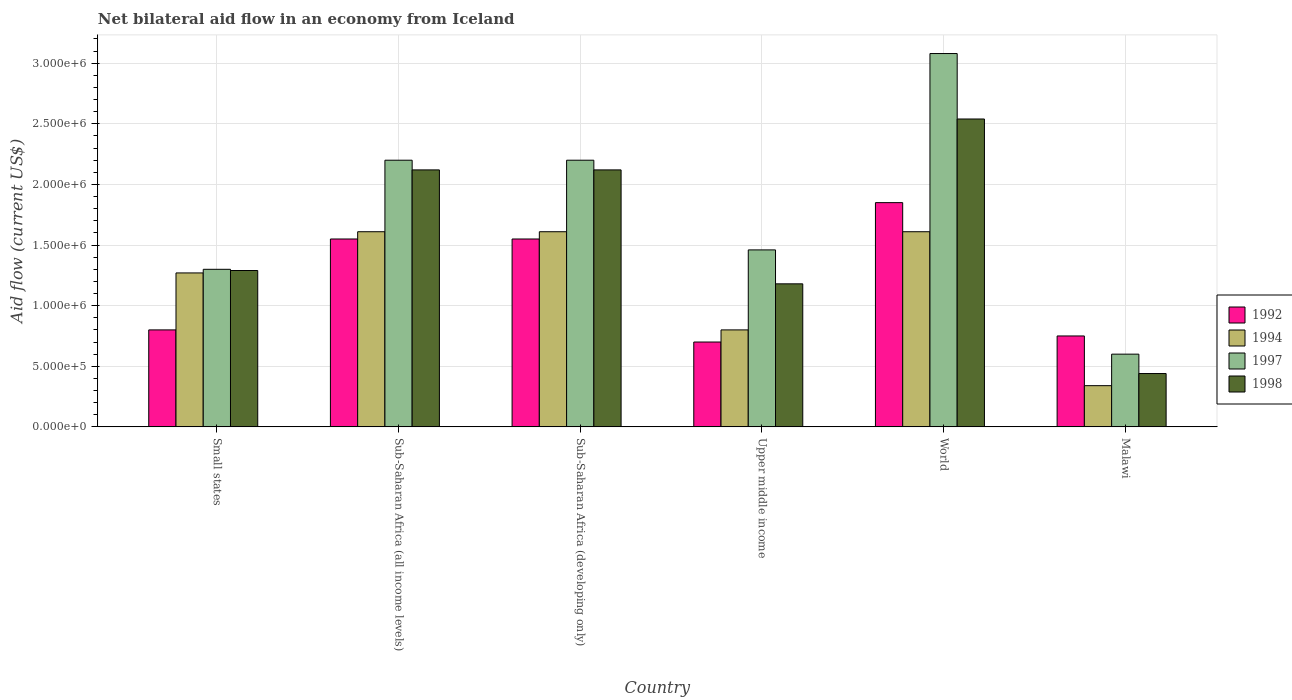How many different coloured bars are there?
Offer a very short reply. 4. How many groups of bars are there?
Your response must be concise. 6. How many bars are there on the 5th tick from the right?
Keep it short and to the point. 4. What is the label of the 6th group of bars from the left?
Ensure brevity in your answer.  Malawi. In how many cases, is the number of bars for a given country not equal to the number of legend labels?
Provide a short and direct response. 0. What is the net bilateral aid flow in 1994 in Upper middle income?
Provide a succinct answer. 8.00e+05. Across all countries, what is the maximum net bilateral aid flow in 1997?
Provide a succinct answer. 3.08e+06. Across all countries, what is the minimum net bilateral aid flow in 1992?
Make the answer very short. 7.00e+05. In which country was the net bilateral aid flow in 1994 maximum?
Your response must be concise. Sub-Saharan Africa (all income levels). In which country was the net bilateral aid flow in 1994 minimum?
Offer a very short reply. Malawi. What is the total net bilateral aid flow in 1992 in the graph?
Provide a short and direct response. 7.20e+06. What is the difference between the net bilateral aid flow in 1998 in Malawi and that in Sub-Saharan Africa (developing only)?
Your response must be concise. -1.68e+06. What is the difference between the net bilateral aid flow in 1992 in Malawi and the net bilateral aid flow in 1998 in Upper middle income?
Your answer should be very brief. -4.30e+05. What is the average net bilateral aid flow in 1997 per country?
Give a very brief answer. 1.81e+06. What is the difference between the net bilateral aid flow of/in 1994 and net bilateral aid flow of/in 1992 in Malawi?
Ensure brevity in your answer.  -4.10e+05. What is the ratio of the net bilateral aid flow in 1994 in Sub-Saharan Africa (developing only) to that in Upper middle income?
Make the answer very short. 2.01. What is the difference between the highest and the lowest net bilateral aid flow in 1992?
Your response must be concise. 1.15e+06. Is the sum of the net bilateral aid flow in 1992 in Sub-Saharan Africa (developing only) and Upper middle income greater than the maximum net bilateral aid flow in 1998 across all countries?
Ensure brevity in your answer.  No. How many bars are there?
Your answer should be very brief. 24. What is the title of the graph?
Make the answer very short. Net bilateral aid flow in an economy from Iceland. What is the label or title of the X-axis?
Make the answer very short. Country. What is the label or title of the Y-axis?
Your answer should be compact. Aid flow (current US$). What is the Aid flow (current US$) of 1992 in Small states?
Provide a succinct answer. 8.00e+05. What is the Aid flow (current US$) of 1994 in Small states?
Offer a very short reply. 1.27e+06. What is the Aid flow (current US$) of 1997 in Small states?
Provide a succinct answer. 1.30e+06. What is the Aid flow (current US$) of 1998 in Small states?
Offer a terse response. 1.29e+06. What is the Aid flow (current US$) of 1992 in Sub-Saharan Africa (all income levels)?
Offer a very short reply. 1.55e+06. What is the Aid flow (current US$) of 1994 in Sub-Saharan Africa (all income levels)?
Your response must be concise. 1.61e+06. What is the Aid flow (current US$) of 1997 in Sub-Saharan Africa (all income levels)?
Your answer should be compact. 2.20e+06. What is the Aid flow (current US$) of 1998 in Sub-Saharan Africa (all income levels)?
Make the answer very short. 2.12e+06. What is the Aid flow (current US$) of 1992 in Sub-Saharan Africa (developing only)?
Offer a terse response. 1.55e+06. What is the Aid flow (current US$) in 1994 in Sub-Saharan Africa (developing only)?
Your answer should be compact. 1.61e+06. What is the Aid flow (current US$) in 1997 in Sub-Saharan Africa (developing only)?
Your answer should be very brief. 2.20e+06. What is the Aid flow (current US$) of 1998 in Sub-Saharan Africa (developing only)?
Provide a succinct answer. 2.12e+06. What is the Aid flow (current US$) in 1992 in Upper middle income?
Provide a short and direct response. 7.00e+05. What is the Aid flow (current US$) of 1994 in Upper middle income?
Keep it short and to the point. 8.00e+05. What is the Aid flow (current US$) in 1997 in Upper middle income?
Offer a terse response. 1.46e+06. What is the Aid flow (current US$) of 1998 in Upper middle income?
Keep it short and to the point. 1.18e+06. What is the Aid flow (current US$) in 1992 in World?
Your response must be concise. 1.85e+06. What is the Aid flow (current US$) of 1994 in World?
Your answer should be compact. 1.61e+06. What is the Aid flow (current US$) of 1997 in World?
Provide a succinct answer. 3.08e+06. What is the Aid flow (current US$) in 1998 in World?
Provide a succinct answer. 2.54e+06. What is the Aid flow (current US$) in 1992 in Malawi?
Keep it short and to the point. 7.50e+05. What is the Aid flow (current US$) of 1994 in Malawi?
Ensure brevity in your answer.  3.40e+05. What is the Aid flow (current US$) in 1997 in Malawi?
Make the answer very short. 6.00e+05. Across all countries, what is the maximum Aid flow (current US$) of 1992?
Provide a succinct answer. 1.85e+06. Across all countries, what is the maximum Aid flow (current US$) of 1994?
Keep it short and to the point. 1.61e+06. Across all countries, what is the maximum Aid flow (current US$) of 1997?
Your answer should be compact. 3.08e+06. Across all countries, what is the maximum Aid flow (current US$) in 1998?
Keep it short and to the point. 2.54e+06. Across all countries, what is the minimum Aid flow (current US$) of 1997?
Provide a succinct answer. 6.00e+05. Across all countries, what is the minimum Aid flow (current US$) in 1998?
Provide a succinct answer. 4.40e+05. What is the total Aid flow (current US$) in 1992 in the graph?
Offer a very short reply. 7.20e+06. What is the total Aid flow (current US$) in 1994 in the graph?
Your answer should be very brief. 7.24e+06. What is the total Aid flow (current US$) in 1997 in the graph?
Ensure brevity in your answer.  1.08e+07. What is the total Aid flow (current US$) of 1998 in the graph?
Make the answer very short. 9.69e+06. What is the difference between the Aid flow (current US$) in 1992 in Small states and that in Sub-Saharan Africa (all income levels)?
Provide a succinct answer. -7.50e+05. What is the difference between the Aid flow (current US$) in 1994 in Small states and that in Sub-Saharan Africa (all income levels)?
Keep it short and to the point. -3.40e+05. What is the difference between the Aid flow (current US$) in 1997 in Small states and that in Sub-Saharan Africa (all income levels)?
Ensure brevity in your answer.  -9.00e+05. What is the difference between the Aid flow (current US$) in 1998 in Small states and that in Sub-Saharan Africa (all income levels)?
Keep it short and to the point. -8.30e+05. What is the difference between the Aid flow (current US$) of 1992 in Small states and that in Sub-Saharan Africa (developing only)?
Keep it short and to the point. -7.50e+05. What is the difference between the Aid flow (current US$) in 1994 in Small states and that in Sub-Saharan Africa (developing only)?
Keep it short and to the point. -3.40e+05. What is the difference between the Aid flow (current US$) in 1997 in Small states and that in Sub-Saharan Africa (developing only)?
Give a very brief answer. -9.00e+05. What is the difference between the Aid flow (current US$) of 1998 in Small states and that in Sub-Saharan Africa (developing only)?
Provide a short and direct response. -8.30e+05. What is the difference between the Aid flow (current US$) in 1992 in Small states and that in Upper middle income?
Make the answer very short. 1.00e+05. What is the difference between the Aid flow (current US$) of 1994 in Small states and that in Upper middle income?
Keep it short and to the point. 4.70e+05. What is the difference between the Aid flow (current US$) of 1992 in Small states and that in World?
Provide a short and direct response. -1.05e+06. What is the difference between the Aid flow (current US$) of 1994 in Small states and that in World?
Offer a terse response. -3.40e+05. What is the difference between the Aid flow (current US$) of 1997 in Small states and that in World?
Your response must be concise. -1.78e+06. What is the difference between the Aid flow (current US$) in 1998 in Small states and that in World?
Keep it short and to the point. -1.25e+06. What is the difference between the Aid flow (current US$) in 1994 in Small states and that in Malawi?
Give a very brief answer. 9.30e+05. What is the difference between the Aid flow (current US$) of 1997 in Small states and that in Malawi?
Keep it short and to the point. 7.00e+05. What is the difference between the Aid flow (current US$) in 1998 in Small states and that in Malawi?
Your answer should be very brief. 8.50e+05. What is the difference between the Aid flow (current US$) of 1992 in Sub-Saharan Africa (all income levels) and that in Sub-Saharan Africa (developing only)?
Your response must be concise. 0. What is the difference between the Aid flow (current US$) of 1997 in Sub-Saharan Africa (all income levels) and that in Sub-Saharan Africa (developing only)?
Provide a succinct answer. 0. What is the difference between the Aid flow (current US$) of 1992 in Sub-Saharan Africa (all income levels) and that in Upper middle income?
Ensure brevity in your answer.  8.50e+05. What is the difference between the Aid flow (current US$) in 1994 in Sub-Saharan Africa (all income levels) and that in Upper middle income?
Make the answer very short. 8.10e+05. What is the difference between the Aid flow (current US$) in 1997 in Sub-Saharan Africa (all income levels) and that in Upper middle income?
Your answer should be very brief. 7.40e+05. What is the difference between the Aid flow (current US$) of 1998 in Sub-Saharan Africa (all income levels) and that in Upper middle income?
Make the answer very short. 9.40e+05. What is the difference between the Aid flow (current US$) in 1994 in Sub-Saharan Africa (all income levels) and that in World?
Your response must be concise. 0. What is the difference between the Aid flow (current US$) in 1997 in Sub-Saharan Africa (all income levels) and that in World?
Provide a succinct answer. -8.80e+05. What is the difference between the Aid flow (current US$) of 1998 in Sub-Saharan Africa (all income levels) and that in World?
Your answer should be very brief. -4.20e+05. What is the difference between the Aid flow (current US$) of 1992 in Sub-Saharan Africa (all income levels) and that in Malawi?
Your answer should be compact. 8.00e+05. What is the difference between the Aid flow (current US$) of 1994 in Sub-Saharan Africa (all income levels) and that in Malawi?
Keep it short and to the point. 1.27e+06. What is the difference between the Aid flow (current US$) of 1997 in Sub-Saharan Africa (all income levels) and that in Malawi?
Make the answer very short. 1.60e+06. What is the difference between the Aid flow (current US$) of 1998 in Sub-Saharan Africa (all income levels) and that in Malawi?
Offer a very short reply. 1.68e+06. What is the difference between the Aid flow (current US$) in 1992 in Sub-Saharan Africa (developing only) and that in Upper middle income?
Provide a short and direct response. 8.50e+05. What is the difference between the Aid flow (current US$) of 1994 in Sub-Saharan Africa (developing only) and that in Upper middle income?
Make the answer very short. 8.10e+05. What is the difference between the Aid flow (current US$) of 1997 in Sub-Saharan Africa (developing only) and that in Upper middle income?
Your answer should be very brief. 7.40e+05. What is the difference between the Aid flow (current US$) of 1998 in Sub-Saharan Africa (developing only) and that in Upper middle income?
Your response must be concise. 9.40e+05. What is the difference between the Aid flow (current US$) of 1994 in Sub-Saharan Africa (developing only) and that in World?
Make the answer very short. 0. What is the difference between the Aid flow (current US$) of 1997 in Sub-Saharan Africa (developing only) and that in World?
Provide a succinct answer. -8.80e+05. What is the difference between the Aid flow (current US$) in 1998 in Sub-Saharan Africa (developing only) and that in World?
Your response must be concise. -4.20e+05. What is the difference between the Aid flow (current US$) of 1994 in Sub-Saharan Africa (developing only) and that in Malawi?
Make the answer very short. 1.27e+06. What is the difference between the Aid flow (current US$) in 1997 in Sub-Saharan Africa (developing only) and that in Malawi?
Ensure brevity in your answer.  1.60e+06. What is the difference between the Aid flow (current US$) of 1998 in Sub-Saharan Africa (developing only) and that in Malawi?
Give a very brief answer. 1.68e+06. What is the difference between the Aid flow (current US$) of 1992 in Upper middle income and that in World?
Provide a succinct answer. -1.15e+06. What is the difference between the Aid flow (current US$) of 1994 in Upper middle income and that in World?
Offer a very short reply. -8.10e+05. What is the difference between the Aid flow (current US$) in 1997 in Upper middle income and that in World?
Your response must be concise. -1.62e+06. What is the difference between the Aid flow (current US$) of 1998 in Upper middle income and that in World?
Your answer should be very brief. -1.36e+06. What is the difference between the Aid flow (current US$) in 1997 in Upper middle income and that in Malawi?
Keep it short and to the point. 8.60e+05. What is the difference between the Aid flow (current US$) of 1998 in Upper middle income and that in Malawi?
Give a very brief answer. 7.40e+05. What is the difference between the Aid flow (current US$) of 1992 in World and that in Malawi?
Keep it short and to the point. 1.10e+06. What is the difference between the Aid flow (current US$) in 1994 in World and that in Malawi?
Your response must be concise. 1.27e+06. What is the difference between the Aid flow (current US$) in 1997 in World and that in Malawi?
Your answer should be compact. 2.48e+06. What is the difference between the Aid flow (current US$) of 1998 in World and that in Malawi?
Provide a short and direct response. 2.10e+06. What is the difference between the Aid flow (current US$) of 1992 in Small states and the Aid flow (current US$) of 1994 in Sub-Saharan Africa (all income levels)?
Provide a short and direct response. -8.10e+05. What is the difference between the Aid flow (current US$) of 1992 in Small states and the Aid flow (current US$) of 1997 in Sub-Saharan Africa (all income levels)?
Make the answer very short. -1.40e+06. What is the difference between the Aid flow (current US$) in 1992 in Small states and the Aid flow (current US$) in 1998 in Sub-Saharan Africa (all income levels)?
Give a very brief answer. -1.32e+06. What is the difference between the Aid flow (current US$) in 1994 in Small states and the Aid flow (current US$) in 1997 in Sub-Saharan Africa (all income levels)?
Your response must be concise. -9.30e+05. What is the difference between the Aid flow (current US$) of 1994 in Small states and the Aid flow (current US$) of 1998 in Sub-Saharan Africa (all income levels)?
Keep it short and to the point. -8.50e+05. What is the difference between the Aid flow (current US$) of 1997 in Small states and the Aid flow (current US$) of 1998 in Sub-Saharan Africa (all income levels)?
Offer a very short reply. -8.20e+05. What is the difference between the Aid flow (current US$) in 1992 in Small states and the Aid flow (current US$) in 1994 in Sub-Saharan Africa (developing only)?
Your response must be concise. -8.10e+05. What is the difference between the Aid flow (current US$) of 1992 in Small states and the Aid flow (current US$) of 1997 in Sub-Saharan Africa (developing only)?
Your answer should be compact. -1.40e+06. What is the difference between the Aid flow (current US$) of 1992 in Small states and the Aid flow (current US$) of 1998 in Sub-Saharan Africa (developing only)?
Offer a terse response. -1.32e+06. What is the difference between the Aid flow (current US$) in 1994 in Small states and the Aid flow (current US$) in 1997 in Sub-Saharan Africa (developing only)?
Ensure brevity in your answer.  -9.30e+05. What is the difference between the Aid flow (current US$) of 1994 in Small states and the Aid flow (current US$) of 1998 in Sub-Saharan Africa (developing only)?
Keep it short and to the point. -8.50e+05. What is the difference between the Aid flow (current US$) in 1997 in Small states and the Aid flow (current US$) in 1998 in Sub-Saharan Africa (developing only)?
Offer a very short reply. -8.20e+05. What is the difference between the Aid flow (current US$) in 1992 in Small states and the Aid flow (current US$) in 1997 in Upper middle income?
Provide a succinct answer. -6.60e+05. What is the difference between the Aid flow (current US$) in 1992 in Small states and the Aid flow (current US$) in 1998 in Upper middle income?
Your response must be concise. -3.80e+05. What is the difference between the Aid flow (current US$) in 1994 in Small states and the Aid flow (current US$) in 1997 in Upper middle income?
Offer a very short reply. -1.90e+05. What is the difference between the Aid flow (current US$) in 1994 in Small states and the Aid flow (current US$) in 1998 in Upper middle income?
Keep it short and to the point. 9.00e+04. What is the difference between the Aid flow (current US$) in 1997 in Small states and the Aid flow (current US$) in 1998 in Upper middle income?
Keep it short and to the point. 1.20e+05. What is the difference between the Aid flow (current US$) of 1992 in Small states and the Aid flow (current US$) of 1994 in World?
Your answer should be very brief. -8.10e+05. What is the difference between the Aid flow (current US$) in 1992 in Small states and the Aid flow (current US$) in 1997 in World?
Your answer should be very brief. -2.28e+06. What is the difference between the Aid flow (current US$) of 1992 in Small states and the Aid flow (current US$) of 1998 in World?
Offer a terse response. -1.74e+06. What is the difference between the Aid flow (current US$) in 1994 in Small states and the Aid flow (current US$) in 1997 in World?
Ensure brevity in your answer.  -1.81e+06. What is the difference between the Aid flow (current US$) of 1994 in Small states and the Aid flow (current US$) of 1998 in World?
Your response must be concise. -1.27e+06. What is the difference between the Aid flow (current US$) of 1997 in Small states and the Aid flow (current US$) of 1998 in World?
Offer a very short reply. -1.24e+06. What is the difference between the Aid flow (current US$) in 1992 in Small states and the Aid flow (current US$) in 1997 in Malawi?
Your answer should be compact. 2.00e+05. What is the difference between the Aid flow (current US$) of 1994 in Small states and the Aid flow (current US$) of 1997 in Malawi?
Give a very brief answer. 6.70e+05. What is the difference between the Aid flow (current US$) of 1994 in Small states and the Aid flow (current US$) of 1998 in Malawi?
Your answer should be compact. 8.30e+05. What is the difference between the Aid flow (current US$) of 1997 in Small states and the Aid flow (current US$) of 1998 in Malawi?
Offer a very short reply. 8.60e+05. What is the difference between the Aid flow (current US$) in 1992 in Sub-Saharan Africa (all income levels) and the Aid flow (current US$) in 1994 in Sub-Saharan Africa (developing only)?
Your answer should be compact. -6.00e+04. What is the difference between the Aid flow (current US$) of 1992 in Sub-Saharan Africa (all income levels) and the Aid flow (current US$) of 1997 in Sub-Saharan Africa (developing only)?
Your response must be concise. -6.50e+05. What is the difference between the Aid flow (current US$) of 1992 in Sub-Saharan Africa (all income levels) and the Aid flow (current US$) of 1998 in Sub-Saharan Africa (developing only)?
Ensure brevity in your answer.  -5.70e+05. What is the difference between the Aid flow (current US$) in 1994 in Sub-Saharan Africa (all income levels) and the Aid flow (current US$) in 1997 in Sub-Saharan Africa (developing only)?
Offer a very short reply. -5.90e+05. What is the difference between the Aid flow (current US$) of 1994 in Sub-Saharan Africa (all income levels) and the Aid flow (current US$) of 1998 in Sub-Saharan Africa (developing only)?
Provide a succinct answer. -5.10e+05. What is the difference between the Aid flow (current US$) of 1992 in Sub-Saharan Africa (all income levels) and the Aid flow (current US$) of 1994 in Upper middle income?
Offer a very short reply. 7.50e+05. What is the difference between the Aid flow (current US$) of 1992 in Sub-Saharan Africa (all income levels) and the Aid flow (current US$) of 1997 in Upper middle income?
Give a very brief answer. 9.00e+04. What is the difference between the Aid flow (current US$) in 1994 in Sub-Saharan Africa (all income levels) and the Aid flow (current US$) in 1998 in Upper middle income?
Your response must be concise. 4.30e+05. What is the difference between the Aid flow (current US$) of 1997 in Sub-Saharan Africa (all income levels) and the Aid flow (current US$) of 1998 in Upper middle income?
Ensure brevity in your answer.  1.02e+06. What is the difference between the Aid flow (current US$) of 1992 in Sub-Saharan Africa (all income levels) and the Aid flow (current US$) of 1994 in World?
Ensure brevity in your answer.  -6.00e+04. What is the difference between the Aid flow (current US$) in 1992 in Sub-Saharan Africa (all income levels) and the Aid flow (current US$) in 1997 in World?
Provide a short and direct response. -1.53e+06. What is the difference between the Aid flow (current US$) of 1992 in Sub-Saharan Africa (all income levels) and the Aid flow (current US$) of 1998 in World?
Your answer should be very brief. -9.90e+05. What is the difference between the Aid flow (current US$) in 1994 in Sub-Saharan Africa (all income levels) and the Aid flow (current US$) in 1997 in World?
Keep it short and to the point. -1.47e+06. What is the difference between the Aid flow (current US$) of 1994 in Sub-Saharan Africa (all income levels) and the Aid flow (current US$) of 1998 in World?
Your response must be concise. -9.30e+05. What is the difference between the Aid flow (current US$) of 1992 in Sub-Saharan Africa (all income levels) and the Aid flow (current US$) of 1994 in Malawi?
Make the answer very short. 1.21e+06. What is the difference between the Aid flow (current US$) in 1992 in Sub-Saharan Africa (all income levels) and the Aid flow (current US$) in 1997 in Malawi?
Provide a succinct answer. 9.50e+05. What is the difference between the Aid flow (current US$) in 1992 in Sub-Saharan Africa (all income levels) and the Aid flow (current US$) in 1998 in Malawi?
Offer a very short reply. 1.11e+06. What is the difference between the Aid flow (current US$) of 1994 in Sub-Saharan Africa (all income levels) and the Aid flow (current US$) of 1997 in Malawi?
Keep it short and to the point. 1.01e+06. What is the difference between the Aid flow (current US$) of 1994 in Sub-Saharan Africa (all income levels) and the Aid flow (current US$) of 1998 in Malawi?
Your response must be concise. 1.17e+06. What is the difference between the Aid flow (current US$) of 1997 in Sub-Saharan Africa (all income levels) and the Aid flow (current US$) of 1998 in Malawi?
Your answer should be compact. 1.76e+06. What is the difference between the Aid flow (current US$) of 1992 in Sub-Saharan Africa (developing only) and the Aid flow (current US$) of 1994 in Upper middle income?
Make the answer very short. 7.50e+05. What is the difference between the Aid flow (current US$) in 1997 in Sub-Saharan Africa (developing only) and the Aid flow (current US$) in 1998 in Upper middle income?
Your answer should be very brief. 1.02e+06. What is the difference between the Aid flow (current US$) of 1992 in Sub-Saharan Africa (developing only) and the Aid flow (current US$) of 1994 in World?
Make the answer very short. -6.00e+04. What is the difference between the Aid flow (current US$) in 1992 in Sub-Saharan Africa (developing only) and the Aid flow (current US$) in 1997 in World?
Your answer should be very brief. -1.53e+06. What is the difference between the Aid flow (current US$) of 1992 in Sub-Saharan Africa (developing only) and the Aid flow (current US$) of 1998 in World?
Keep it short and to the point. -9.90e+05. What is the difference between the Aid flow (current US$) of 1994 in Sub-Saharan Africa (developing only) and the Aid flow (current US$) of 1997 in World?
Keep it short and to the point. -1.47e+06. What is the difference between the Aid flow (current US$) of 1994 in Sub-Saharan Africa (developing only) and the Aid flow (current US$) of 1998 in World?
Make the answer very short. -9.30e+05. What is the difference between the Aid flow (current US$) in 1997 in Sub-Saharan Africa (developing only) and the Aid flow (current US$) in 1998 in World?
Offer a very short reply. -3.40e+05. What is the difference between the Aid flow (current US$) of 1992 in Sub-Saharan Africa (developing only) and the Aid flow (current US$) of 1994 in Malawi?
Ensure brevity in your answer.  1.21e+06. What is the difference between the Aid flow (current US$) in 1992 in Sub-Saharan Africa (developing only) and the Aid flow (current US$) in 1997 in Malawi?
Offer a very short reply. 9.50e+05. What is the difference between the Aid flow (current US$) in 1992 in Sub-Saharan Africa (developing only) and the Aid flow (current US$) in 1998 in Malawi?
Your answer should be compact. 1.11e+06. What is the difference between the Aid flow (current US$) in 1994 in Sub-Saharan Africa (developing only) and the Aid flow (current US$) in 1997 in Malawi?
Keep it short and to the point. 1.01e+06. What is the difference between the Aid flow (current US$) in 1994 in Sub-Saharan Africa (developing only) and the Aid flow (current US$) in 1998 in Malawi?
Offer a terse response. 1.17e+06. What is the difference between the Aid flow (current US$) in 1997 in Sub-Saharan Africa (developing only) and the Aid flow (current US$) in 1998 in Malawi?
Your response must be concise. 1.76e+06. What is the difference between the Aid flow (current US$) of 1992 in Upper middle income and the Aid flow (current US$) of 1994 in World?
Ensure brevity in your answer.  -9.10e+05. What is the difference between the Aid flow (current US$) of 1992 in Upper middle income and the Aid flow (current US$) of 1997 in World?
Your answer should be very brief. -2.38e+06. What is the difference between the Aid flow (current US$) of 1992 in Upper middle income and the Aid flow (current US$) of 1998 in World?
Make the answer very short. -1.84e+06. What is the difference between the Aid flow (current US$) of 1994 in Upper middle income and the Aid flow (current US$) of 1997 in World?
Provide a succinct answer. -2.28e+06. What is the difference between the Aid flow (current US$) in 1994 in Upper middle income and the Aid flow (current US$) in 1998 in World?
Make the answer very short. -1.74e+06. What is the difference between the Aid flow (current US$) of 1997 in Upper middle income and the Aid flow (current US$) of 1998 in World?
Offer a terse response. -1.08e+06. What is the difference between the Aid flow (current US$) of 1994 in Upper middle income and the Aid flow (current US$) of 1998 in Malawi?
Provide a succinct answer. 3.60e+05. What is the difference between the Aid flow (current US$) of 1997 in Upper middle income and the Aid flow (current US$) of 1998 in Malawi?
Offer a terse response. 1.02e+06. What is the difference between the Aid flow (current US$) of 1992 in World and the Aid flow (current US$) of 1994 in Malawi?
Offer a terse response. 1.51e+06. What is the difference between the Aid flow (current US$) of 1992 in World and the Aid flow (current US$) of 1997 in Malawi?
Offer a terse response. 1.25e+06. What is the difference between the Aid flow (current US$) of 1992 in World and the Aid flow (current US$) of 1998 in Malawi?
Provide a short and direct response. 1.41e+06. What is the difference between the Aid flow (current US$) of 1994 in World and the Aid flow (current US$) of 1997 in Malawi?
Keep it short and to the point. 1.01e+06. What is the difference between the Aid flow (current US$) in 1994 in World and the Aid flow (current US$) in 1998 in Malawi?
Provide a succinct answer. 1.17e+06. What is the difference between the Aid flow (current US$) of 1997 in World and the Aid flow (current US$) of 1998 in Malawi?
Make the answer very short. 2.64e+06. What is the average Aid flow (current US$) of 1992 per country?
Give a very brief answer. 1.20e+06. What is the average Aid flow (current US$) of 1994 per country?
Provide a short and direct response. 1.21e+06. What is the average Aid flow (current US$) in 1997 per country?
Provide a short and direct response. 1.81e+06. What is the average Aid flow (current US$) of 1998 per country?
Your answer should be compact. 1.62e+06. What is the difference between the Aid flow (current US$) in 1992 and Aid flow (current US$) in 1994 in Small states?
Ensure brevity in your answer.  -4.70e+05. What is the difference between the Aid flow (current US$) of 1992 and Aid flow (current US$) of 1997 in Small states?
Offer a very short reply. -5.00e+05. What is the difference between the Aid flow (current US$) of 1992 and Aid flow (current US$) of 1998 in Small states?
Provide a short and direct response. -4.90e+05. What is the difference between the Aid flow (current US$) in 1994 and Aid flow (current US$) in 1998 in Small states?
Ensure brevity in your answer.  -2.00e+04. What is the difference between the Aid flow (current US$) in 1992 and Aid flow (current US$) in 1994 in Sub-Saharan Africa (all income levels)?
Offer a very short reply. -6.00e+04. What is the difference between the Aid flow (current US$) of 1992 and Aid flow (current US$) of 1997 in Sub-Saharan Africa (all income levels)?
Offer a very short reply. -6.50e+05. What is the difference between the Aid flow (current US$) in 1992 and Aid flow (current US$) in 1998 in Sub-Saharan Africa (all income levels)?
Provide a succinct answer. -5.70e+05. What is the difference between the Aid flow (current US$) of 1994 and Aid flow (current US$) of 1997 in Sub-Saharan Africa (all income levels)?
Keep it short and to the point. -5.90e+05. What is the difference between the Aid flow (current US$) in 1994 and Aid flow (current US$) in 1998 in Sub-Saharan Africa (all income levels)?
Give a very brief answer. -5.10e+05. What is the difference between the Aid flow (current US$) of 1997 and Aid flow (current US$) of 1998 in Sub-Saharan Africa (all income levels)?
Give a very brief answer. 8.00e+04. What is the difference between the Aid flow (current US$) in 1992 and Aid flow (current US$) in 1997 in Sub-Saharan Africa (developing only)?
Give a very brief answer. -6.50e+05. What is the difference between the Aid flow (current US$) of 1992 and Aid flow (current US$) of 1998 in Sub-Saharan Africa (developing only)?
Offer a terse response. -5.70e+05. What is the difference between the Aid flow (current US$) of 1994 and Aid flow (current US$) of 1997 in Sub-Saharan Africa (developing only)?
Your answer should be very brief. -5.90e+05. What is the difference between the Aid flow (current US$) of 1994 and Aid flow (current US$) of 1998 in Sub-Saharan Africa (developing only)?
Ensure brevity in your answer.  -5.10e+05. What is the difference between the Aid flow (current US$) of 1997 and Aid flow (current US$) of 1998 in Sub-Saharan Africa (developing only)?
Provide a succinct answer. 8.00e+04. What is the difference between the Aid flow (current US$) of 1992 and Aid flow (current US$) of 1997 in Upper middle income?
Give a very brief answer. -7.60e+05. What is the difference between the Aid flow (current US$) of 1992 and Aid flow (current US$) of 1998 in Upper middle income?
Ensure brevity in your answer.  -4.80e+05. What is the difference between the Aid flow (current US$) in 1994 and Aid flow (current US$) in 1997 in Upper middle income?
Give a very brief answer. -6.60e+05. What is the difference between the Aid flow (current US$) in 1994 and Aid flow (current US$) in 1998 in Upper middle income?
Make the answer very short. -3.80e+05. What is the difference between the Aid flow (current US$) in 1992 and Aid flow (current US$) in 1994 in World?
Offer a terse response. 2.40e+05. What is the difference between the Aid flow (current US$) of 1992 and Aid flow (current US$) of 1997 in World?
Offer a very short reply. -1.23e+06. What is the difference between the Aid flow (current US$) in 1992 and Aid flow (current US$) in 1998 in World?
Offer a terse response. -6.90e+05. What is the difference between the Aid flow (current US$) in 1994 and Aid flow (current US$) in 1997 in World?
Ensure brevity in your answer.  -1.47e+06. What is the difference between the Aid flow (current US$) of 1994 and Aid flow (current US$) of 1998 in World?
Provide a short and direct response. -9.30e+05. What is the difference between the Aid flow (current US$) in 1997 and Aid flow (current US$) in 1998 in World?
Your answer should be very brief. 5.40e+05. What is the difference between the Aid flow (current US$) of 1992 and Aid flow (current US$) of 1994 in Malawi?
Your answer should be compact. 4.10e+05. What is the difference between the Aid flow (current US$) in 1992 and Aid flow (current US$) in 1997 in Malawi?
Your answer should be very brief. 1.50e+05. What is the difference between the Aid flow (current US$) in 1994 and Aid flow (current US$) in 1998 in Malawi?
Give a very brief answer. -1.00e+05. What is the ratio of the Aid flow (current US$) of 1992 in Small states to that in Sub-Saharan Africa (all income levels)?
Provide a succinct answer. 0.52. What is the ratio of the Aid flow (current US$) in 1994 in Small states to that in Sub-Saharan Africa (all income levels)?
Ensure brevity in your answer.  0.79. What is the ratio of the Aid flow (current US$) of 1997 in Small states to that in Sub-Saharan Africa (all income levels)?
Ensure brevity in your answer.  0.59. What is the ratio of the Aid flow (current US$) in 1998 in Small states to that in Sub-Saharan Africa (all income levels)?
Make the answer very short. 0.61. What is the ratio of the Aid flow (current US$) in 1992 in Small states to that in Sub-Saharan Africa (developing only)?
Offer a very short reply. 0.52. What is the ratio of the Aid flow (current US$) in 1994 in Small states to that in Sub-Saharan Africa (developing only)?
Keep it short and to the point. 0.79. What is the ratio of the Aid flow (current US$) of 1997 in Small states to that in Sub-Saharan Africa (developing only)?
Provide a short and direct response. 0.59. What is the ratio of the Aid flow (current US$) in 1998 in Small states to that in Sub-Saharan Africa (developing only)?
Provide a succinct answer. 0.61. What is the ratio of the Aid flow (current US$) in 1994 in Small states to that in Upper middle income?
Your response must be concise. 1.59. What is the ratio of the Aid flow (current US$) of 1997 in Small states to that in Upper middle income?
Your answer should be very brief. 0.89. What is the ratio of the Aid flow (current US$) in 1998 in Small states to that in Upper middle income?
Offer a terse response. 1.09. What is the ratio of the Aid flow (current US$) of 1992 in Small states to that in World?
Provide a short and direct response. 0.43. What is the ratio of the Aid flow (current US$) in 1994 in Small states to that in World?
Offer a terse response. 0.79. What is the ratio of the Aid flow (current US$) in 1997 in Small states to that in World?
Make the answer very short. 0.42. What is the ratio of the Aid flow (current US$) of 1998 in Small states to that in World?
Your answer should be very brief. 0.51. What is the ratio of the Aid flow (current US$) in 1992 in Small states to that in Malawi?
Offer a very short reply. 1.07. What is the ratio of the Aid flow (current US$) of 1994 in Small states to that in Malawi?
Make the answer very short. 3.74. What is the ratio of the Aid flow (current US$) of 1997 in Small states to that in Malawi?
Your answer should be compact. 2.17. What is the ratio of the Aid flow (current US$) in 1998 in Small states to that in Malawi?
Provide a succinct answer. 2.93. What is the ratio of the Aid flow (current US$) in 1994 in Sub-Saharan Africa (all income levels) to that in Sub-Saharan Africa (developing only)?
Ensure brevity in your answer.  1. What is the ratio of the Aid flow (current US$) in 1998 in Sub-Saharan Africa (all income levels) to that in Sub-Saharan Africa (developing only)?
Ensure brevity in your answer.  1. What is the ratio of the Aid flow (current US$) of 1992 in Sub-Saharan Africa (all income levels) to that in Upper middle income?
Offer a terse response. 2.21. What is the ratio of the Aid flow (current US$) of 1994 in Sub-Saharan Africa (all income levels) to that in Upper middle income?
Offer a terse response. 2.01. What is the ratio of the Aid flow (current US$) of 1997 in Sub-Saharan Africa (all income levels) to that in Upper middle income?
Offer a terse response. 1.51. What is the ratio of the Aid flow (current US$) in 1998 in Sub-Saharan Africa (all income levels) to that in Upper middle income?
Offer a terse response. 1.8. What is the ratio of the Aid flow (current US$) in 1992 in Sub-Saharan Africa (all income levels) to that in World?
Your answer should be very brief. 0.84. What is the ratio of the Aid flow (current US$) in 1997 in Sub-Saharan Africa (all income levels) to that in World?
Your response must be concise. 0.71. What is the ratio of the Aid flow (current US$) of 1998 in Sub-Saharan Africa (all income levels) to that in World?
Give a very brief answer. 0.83. What is the ratio of the Aid flow (current US$) of 1992 in Sub-Saharan Africa (all income levels) to that in Malawi?
Offer a terse response. 2.07. What is the ratio of the Aid flow (current US$) of 1994 in Sub-Saharan Africa (all income levels) to that in Malawi?
Provide a succinct answer. 4.74. What is the ratio of the Aid flow (current US$) in 1997 in Sub-Saharan Africa (all income levels) to that in Malawi?
Make the answer very short. 3.67. What is the ratio of the Aid flow (current US$) of 1998 in Sub-Saharan Africa (all income levels) to that in Malawi?
Your answer should be compact. 4.82. What is the ratio of the Aid flow (current US$) of 1992 in Sub-Saharan Africa (developing only) to that in Upper middle income?
Provide a succinct answer. 2.21. What is the ratio of the Aid flow (current US$) in 1994 in Sub-Saharan Africa (developing only) to that in Upper middle income?
Your response must be concise. 2.01. What is the ratio of the Aid flow (current US$) in 1997 in Sub-Saharan Africa (developing only) to that in Upper middle income?
Ensure brevity in your answer.  1.51. What is the ratio of the Aid flow (current US$) of 1998 in Sub-Saharan Africa (developing only) to that in Upper middle income?
Offer a very short reply. 1.8. What is the ratio of the Aid flow (current US$) in 1992 in Sub-Saharan Africa (developing only) to that in World?
Your response must be concise. 0.84. What is the ratio of the Aid flow (current US$) in 1994 in Sub-Saharan Africa (developing only) to that in World?
Ensure brevity in your answer.  1. What is the ratio of the Aid flow (current US$) of 1997 in Sub-Saharan Africa (developing only) to that in World?
Provide a short and direct response. 0.71. What is the ratio of the Aid flow (current US$) in 1998 in Sub-Saharan Africa (developing only) to that in World?
Offer a terse response. 0.83. What is the ratio of the Aid flow (current US$) in 1992 in Sub-Saharan Africa (developing only) to that in Malawi?
Your answer should be very brief. 2.07. What is the ratio of the Aid flow (current US$) of 1994 in Sub-Saharan Africa (developing only) to that in Malawi?
Make the answer very short. 4.74. What is the ratio of the Aid flow (current US$) of 1997 in Sub-Saharan Africa (developing only) to that in Malawi?
Ensure brevity in your answer.  3.67. What is the ratio of the Aid flow (current US$) of 1998 in Sub-Saharan Africa (developing only) to that in Malawi?
Your answer should be very brief. 4.82. What is the ratio of the Aid flow (current US$) in 1992 in Upper middle income to that in World?
Make the answer very short. 0.38. What is the ratio of the Aid flow (current US$) of 1994 in Upper middle income to that in World?
Provide a short and direct response. 0.5. What is the ratio of the Aid flow (current US$) of 1997 in Upper middle income to that in World?
Give a very brief answer. 0.47. What is the ratio of the Aid flow (current US$) in 1998 in Upper middle income to that in World?
Provide a short and direct response. 0.46. What is the ratio of the Aid flow (current US$) of 1992 in Upper middle income to that in Malawi?
Offer a very short reply. 0.93. What is the ratio of the Aid flow (current US$) of 1994 in Upper middle income to that in Malawi?
Your answer should be compact. 2.35. What is the ratio of the Aid flow (current US$) in 1997 in Upper middle income to that in Malawi?
Your response must be concise. 2.43. What is the ratio of the Aid flow (current US$) of 1998 in Upper middle income to that in Malawi?
Your answer should be compact. 2.68. What is the ratio of the Aid flow (current US$) of 1992 in World to that in Malawi?
Your answer should be compact. 2.47. What is the ratio of the Aid flow (current US$) in 1994 in World to that in Malawi?
Your answer should be very brief. 4.74. What is the ratio of the Aid flow (current US$) in 1997 in World to that in Malawi?
Keep it short and to the point. 5.13. What is the ratio of the Aid flow (current US$) in 1998 in World to that in Malawi?
Your answer should be compact. 5.77. What is the difference between the highest and the second highest Aid flow (current US$) in 1997?
Ensure brevity in your answer.  8.80e+05. What is the difference between the highest and the second highest Aid flow (current US$) of 1998?
Provide a succinct answer. 4.20e+05. What is the difference between the highest and the lowest Aid flow (current US$) of 1992?
Give a very brief answer. 1.15e+06. What is the difference between the highest and the lowest Aid flow (current US$) of 1994?
Offer a very short reply. 1.27e+06. What is the difference between the highest and the lowest Aid flow (current US$) of 1997?
Make the answer very short. 2.48e+06. What is the difference between the highest and the lowest Aid flow (current US$) of 1998?
Provide a short and direct response. 2.10e+06. 